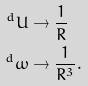Convert formula to latex. <formula><loc_0><loc_0><loc_500><loc_500>^ { d } U & \to \frac { 1 } { R } \\ ^ { d } \omega & \to \frac { 1 } { R ^ { 3 } } .</formula> 